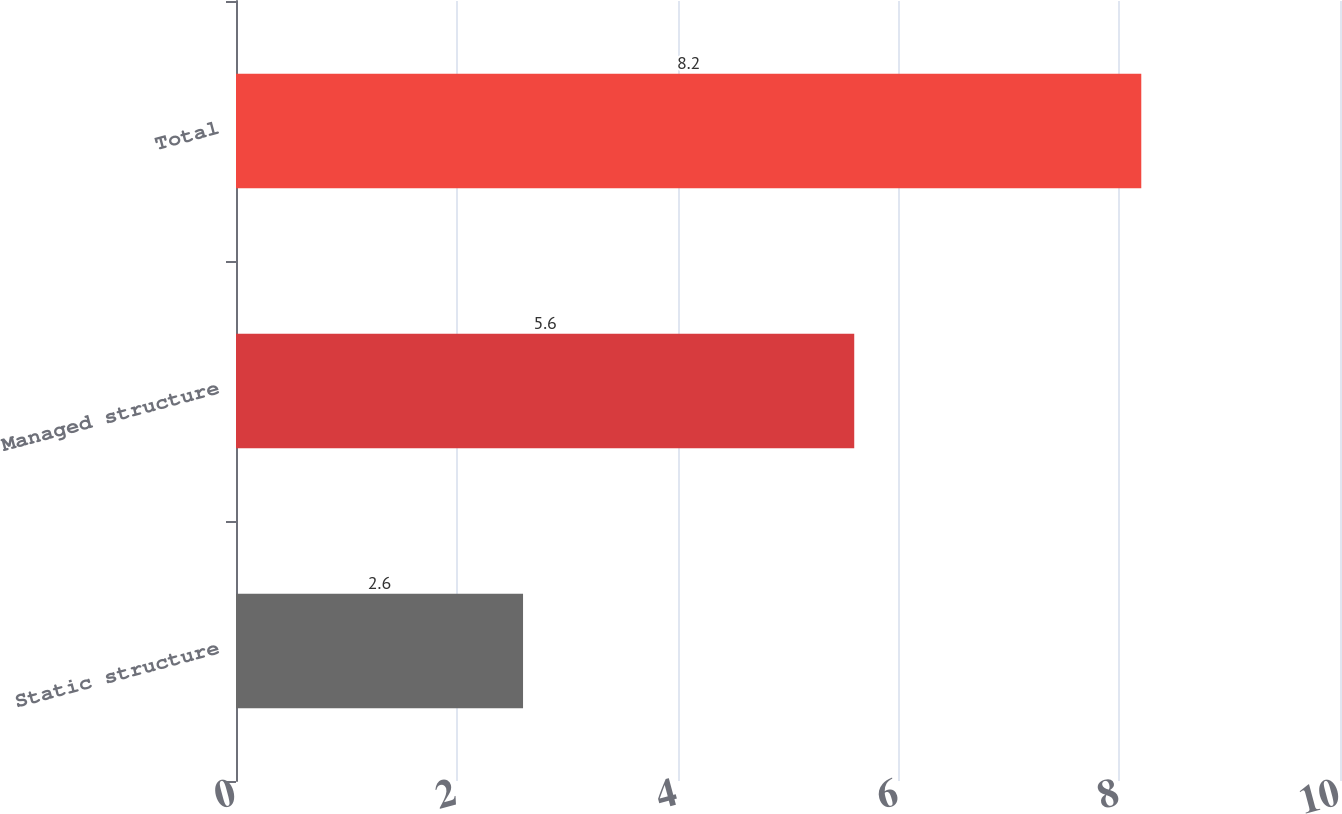<chart> <loc_0><loc_0><loc_500><loc_500><bar_chart><fcel>Static structure<fcel>Managed structure<fcel>Total<nl><fcel>2.6<fcel>5.6<fcel>8.2<nl></chart> 